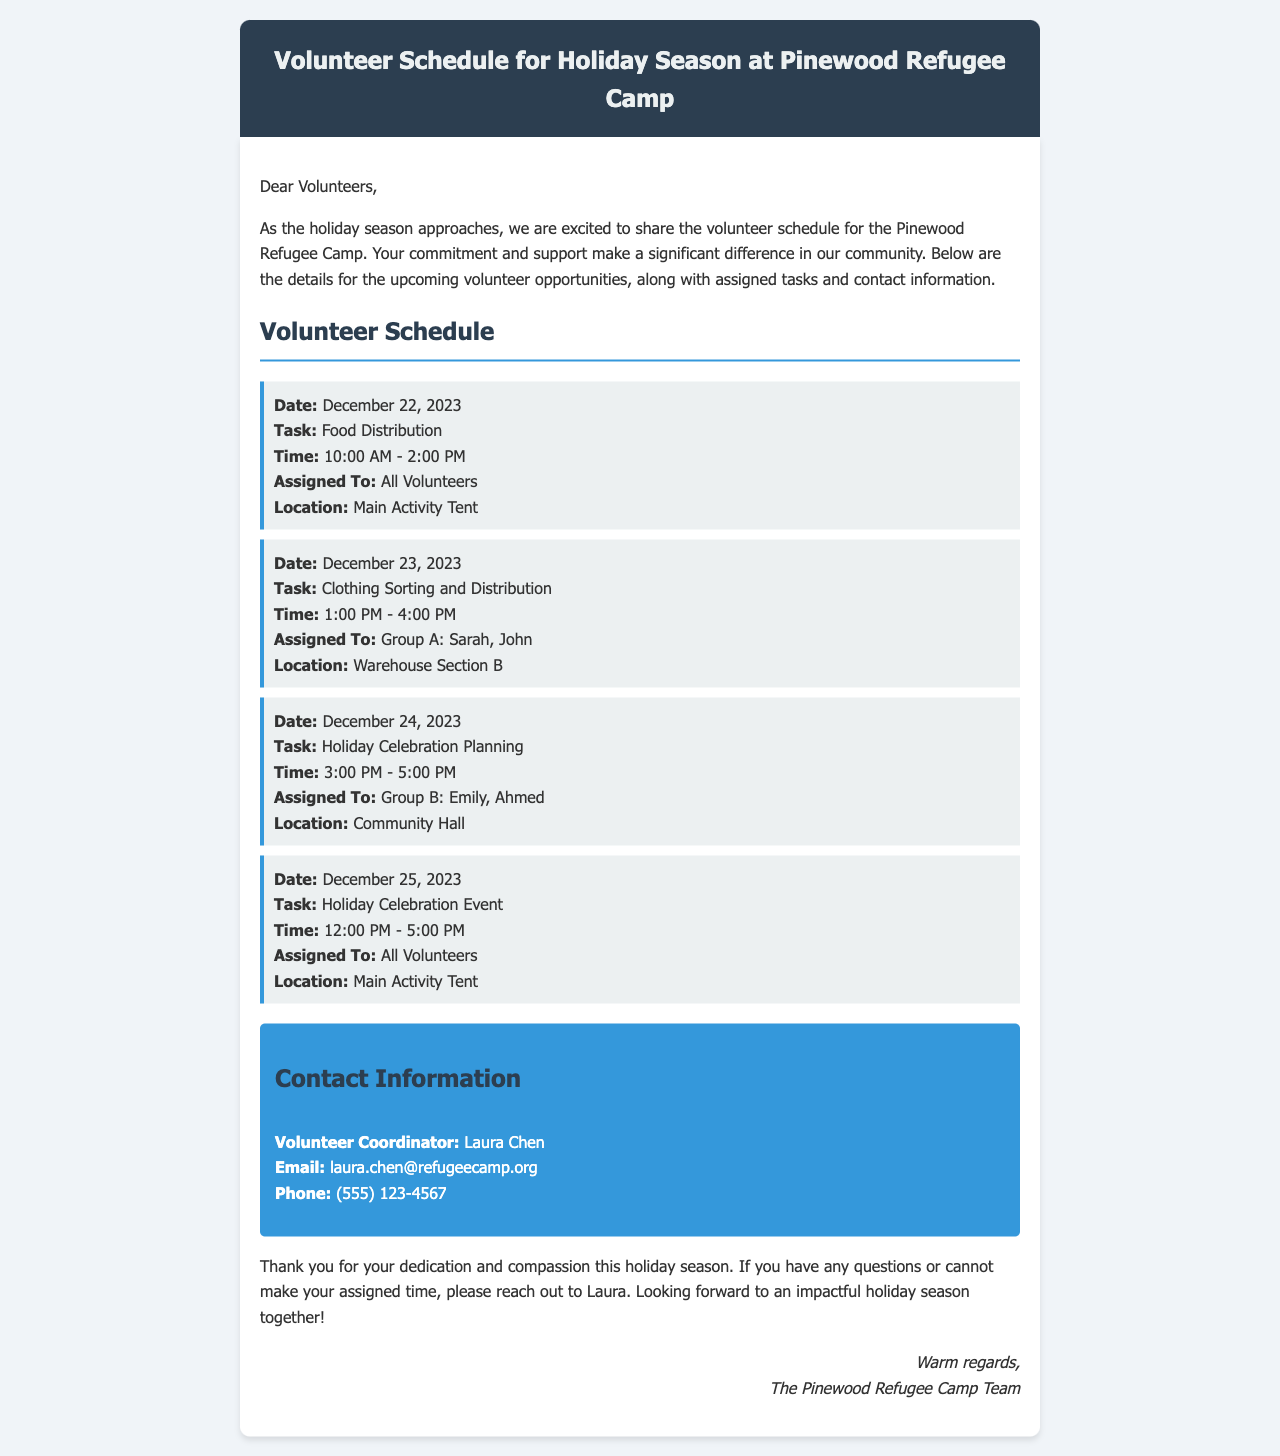what is the date of the food distribution task? The food distribution task is scheduled for December 22, 2023, as detailed in the schedule section.
Answer: December 22, 2023 who is responsible for clothing sorting and distribution? The responsible individuals for clothing sorting and distribution are listed as Sarah and John in Group A.
Answer: Sarah, John what time does the holiday celebration event start? The holiday celebration event is set to start at 12:00 PM, according to the schedule provided.
Answer: 12:00 PM how many hours are allocated for the holiday celebration planning task? The holiday celebration planning task is allocated a time span of 2 hours, from 3:00 PM to 5:00 PM.
Answer: 2 hours who should be contacted for volunteer-related questions? The volunteer coordinator, Laura Chen, is the point of contact for any questions regarding volunteering.
Answer: Laura Chen what is the location for food distribution? The food distribution task is conducted at the Main Activity Tent, as per the location specified.
Answer: Main Activity Tent which groups are mentioned in the schedule? The groups mentioned in the schedule include Group A and Group B for specific tasks.
Answer: Group A, Group B how is the schedule organized in the document? The schedule is organized in chronological order with dates, tasks, times, assigned groups, and locations for each activity.
Answer: Chronological order what is the primary purpose of this email? The primary purpose of the email is to inform volunteers about the holiday season schedule and assigned tasks at the refugee camp.
Answer: Inform volunteers 